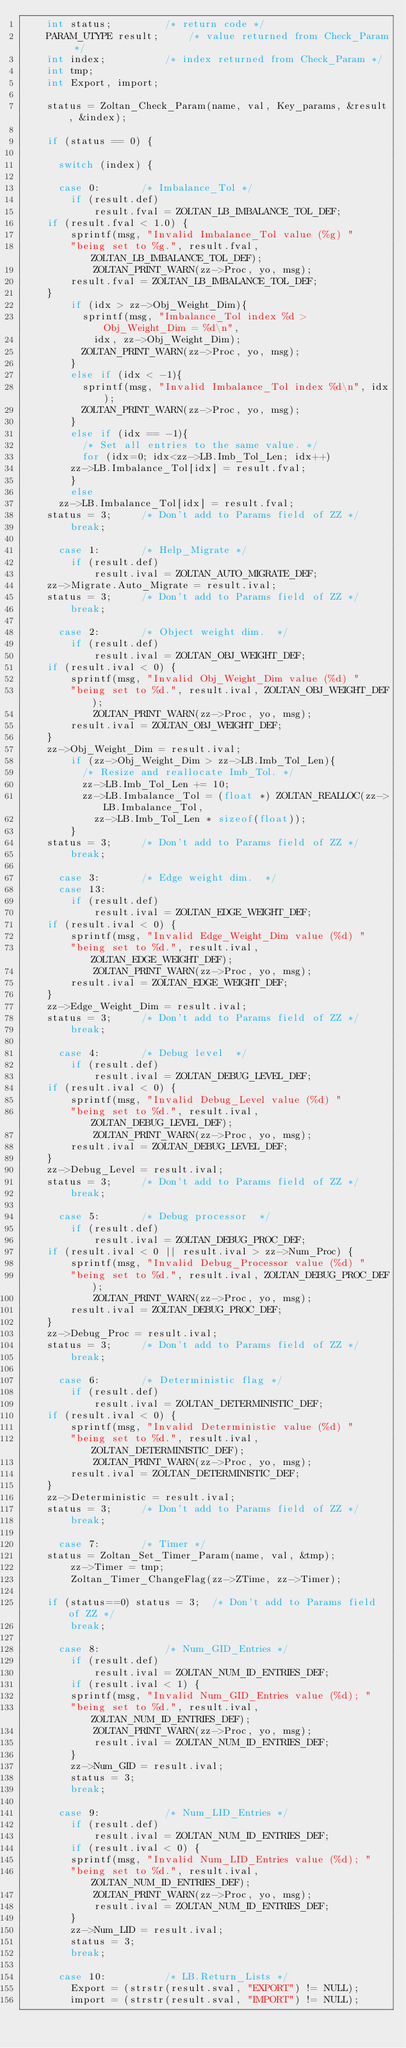<code> <loc_0><loc_0><loc_500><loc_500><_C_>    int status;			/* return code */
    PARAM_UTYPE result;		/* value returned from Check_Param */
    int index;			/* index returned from Check_Param */
    int tmp;
    int Export, import;

    status = Zoltan_Check_Param(name, val, Key_params, &result, &index);

    if (status == 0) {

      switch (index) {

      case 0:  		/* Imbalance_Tol */
        if (result.def) 
            result.fval = ZOLTAN_LB_IMBALANCE_TOL_DEF;
	if (result.fval < 1.0) {
	    sprintf(msg, "Invalid Imbalance_Tol value (%g) "
		"being set to %g.", result.fval, ZOLTAN_LB_IMBALANCE_TOL_DEF);
            ZOLTAN_PRINT_WARN(zz->Proc, yo, msg);
	    result.fval = ZOLTAN_LB_IMBALANCE_TOL_DEF;
	}
        if (idx > zz->Obj_Weight_Dim){
          sprintf(msg, "Imbalance_Tol index %d > Obj_Weight_Dim = %d\n",
            idx, zz->Obj_Weight_Dim);
          ZOLTAN_PRINT_WARN(zz->Proc, yo, msg);
        }
        else if (idx < -1){
          sprintf(msg, "Invalid Imbalance_Tol index %d\n", idx);
          ZOLTAN_PRINT_WARN(zz->Proc, yo, msg);
        }
        else if (idx == -1){
          /* Set all entries to the same value. */
          for (idx=0; idx<zz->LB.Imb_Tol_Len; idx++)
	    zz->LB.Imbalance_Tol[idx] = result.fval;
        }
        else
	  zz->LB.Imbalance_Tol[idx] = result.fval;
	status = 3;		/* Don't add to Params field of ZZ */
        break;

      case 1:		/* Help_Migrate */
        if (result.def)
            result.ival = ZOLTAN_AUTO_MIGRATE_DEF;
	zz->Migrate.Auto_Migrate = result.ival;
	status = 3;		/* Don't add to Params field of ZZ */
        break;

      case 2:		/* Object weight dim.  */
        if (result.def)
            result.ival = ZOLTAN_OBJ_WEIGHT_DEF;
	if (result.ival < 0) {
	    sprintf(msg, "Invalid Obj_Weight_Dim value (%d) "
		"being set to %d.", result.ival, ZOLTAN_OBJ_WEIGHT_DEF);
            ZOLTAN_PRINT_WARN(zz->Proc, yo, msg);
	    result.ival = ZOLTAN_OBJ_WEIGHT_DEF;
	}
	zz->Obj_Weight_Dim = result.ival;
        if (zz->Obj_Weight_Dim > zz->LB.Imb_Tol_Len){
          /* Resize and reallocate Imb_Tol. */
          zz->LB.Imb_Tol_Len += 10;
          zz->LB.Imbalance_Tol = (float *) ZOLTAN_REALLOC(zz->LB.Imbalance_Tol,
            zz->LB.Imb_Tol_Len * sizeof(float));
        }
	status = 3;		/* Don't add to Params field of ZZ */
        break;

      case 3: 		/* Edge weight dim.  */
      case 13:
        if (result.def)
            result.ival = ZOLTAN_EDGE_WEIGHT_DEF;
	if (result.ival < 0) {
	    sprintf(msg, "Invalid Edge_Weight_Dim value (%d) "
		"being set to %d.", result.ival, ZOLTAN_EDGE_WEIGHT_DEF);
            ZOLTAN_PRINT_WARN(zz->Proc, yo, msg);
	    result.ival = ZOLTAN_EDGE_WEIGHT_DEF;
	}
	zz->Edge_Weight_Dim = result.ival;
	status = 3;		/* Don't add to Params field of ZZ */
        break;

      case 4: 		/* Debug level  */
        if (result.def)
            result.ival = ZOLTAN_DEBUG_LEVEL_DEF;
	if (result.ival < 0) {
	    sprintf(msg, "Invalid Debug_Level value (%d) "
		"being set to %d.", result.ival, ZOLTAN_DEBUG_LEVEL_DEF);
            ZOLTAN_PRINT_WARN(zz->Proc, yo, msg);
	    result.ival = ZOLTAN_DEBUG_LEVEL_DEF;
	}
	zz->Debug_Level = result.ival;
	status = 3;		/* Don't add to Params field of ZZ */
        break;

      case 5: 		/* Debug processor  */
        if (result.def)
            result.ival = ZOLTAN_DEBUG_PROC_DEF;
	if (result.ival < 0 || result.ival > zz->Num_Proc) {
	    sprintf(msg, "Invalid Debug_Processor value (%d) "
		"being set to %d.", result.ival, ZOLTAN_DEBUG_PROC_DEF);
            ZOLTAN_PRINT_WARN(zz->Proc, yo, msg);
	    result.ival = ZOLTAN_DEBUG_PROC_DEF;
	}
	zz->Debug_Proc = result.ival;
	status = 3;		/* Don't add to Params field of ZZ */
        break;
       
      case 6: 		/* Deterministic flag */
        if (result.def)
            result.ival = ZOLTAN_DETERMINISTIC_DEF;
	if (result.ival < 0) {
	    sprintf(msg, "Invalid Deterministic value (%d) "
		"being set to %d.", result.ival, ZOLTAN_DETERMINISTIC_DEF);
            ZOLTAN_PRINT_WARN(zz->Proc, yo, msg);
	    result.ival = ZOLTAN_DETERMINISTIC_DEF;
	}
	zz->Deterministic = result.ival;
	status = 3;		/* Don't add to Params field of ZZ */
        break;

      case 7: 		/* Timer */
	status = Zoltan_Set_Timer_Param(name, val, &tmp);
        zz->Timer = tmp;
        Zoltan_Timer_ChangeFlag(zz->ZTime, zz->Timer);

	if (status==0) status = 3;	/* Don't add to Params field of ZZ */
        break;

      case 8:           /* Num_GID_Entries */
        if (result.def)
            result.ival = ZOLTAN_NUM_ID_ENTRIES_DEF;
        if (result.ival < 1) {
	    sprintf(msg, "Invalid Num_GID_Entries value (%d); "
		"being set to %d.", result.ival, ZOLTAN_NUM_ID_ENTRIES_DEF);
            ZOLTAN_PRINT_WARN(zz->Proc, yo, msg);
            result.ival = ZOLTAN_NUM_ID_ENTRIES_DEF;
        }
        zz->Num_GID = result.ival;
        status = 3;
        break;

      case 9:           /* Num_LID_Entries */
        if (result.def)
            result.ival = ZOLTAN_NUM_ID_ENTRIES_DEF;
        if (result.ival < 0) {
	    sprintf(msg, "Invalid Num_LID_Entries value (%d); "
		"being set to %d.", result.ival, ZOLTAN_NUM_ID_ENTRIES_DEF);
            ZOLTAN_PRINT_WARN(zz->Proc, yo, msg);
            result.ival = ZOLTAN_NUM_ID_ENTRIES_DEF;
        }
        zz->Num_LID = result.ival;
        status = 3;
        break;

      case 10:          /* LB.Return_Lists */
        Export = (strstr(result.sval, "EXPORT") != NULL);
        import = (strstr(result.sval, "IMPORT") != NULL);</code> 